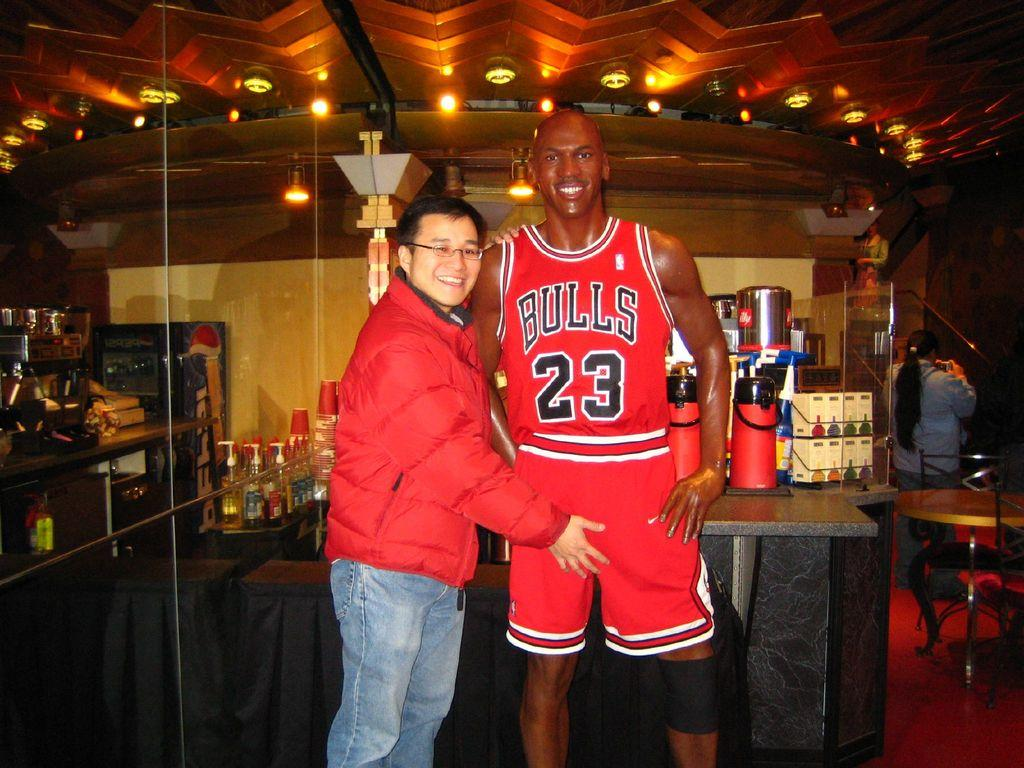<image>
Describe the image concisely. A man stands behind a figure of a Bulls player number 23. 